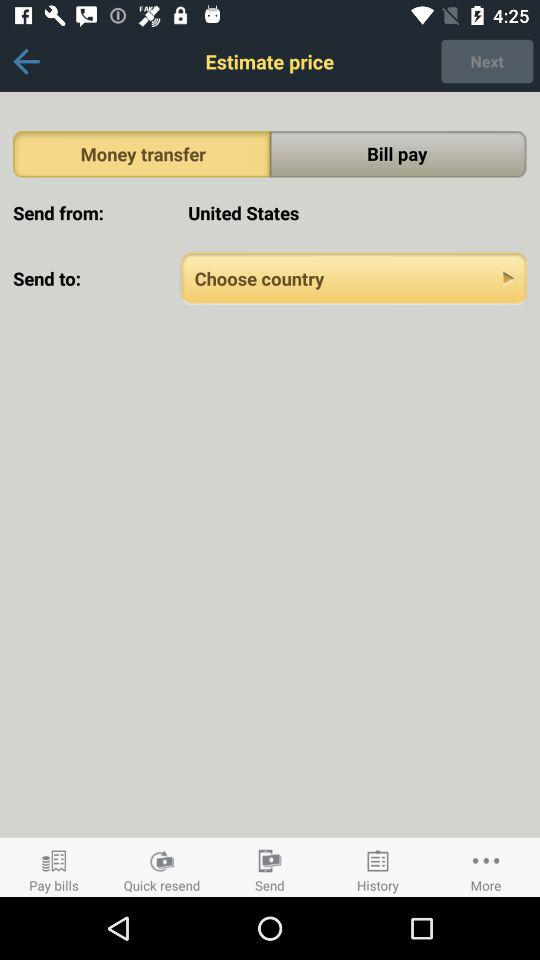From which country has the money been sent? The money is sent from the United States. 